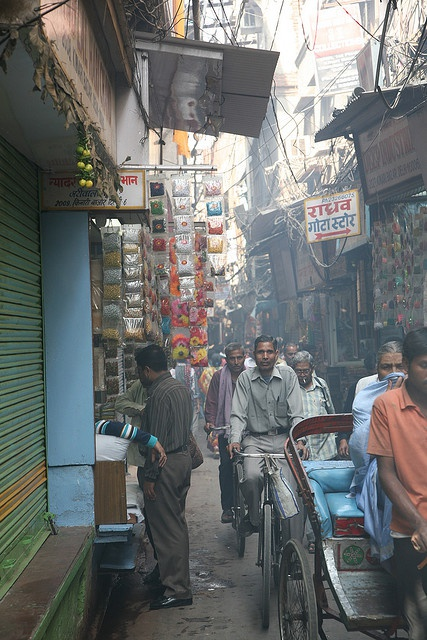Describe the objects in this image and their specific colors. I can see people in black, gray, and salmon tones, people in black, gray, darkgray, and purple tones, people in black, gray, and purple tones, people in black, gray, and blue tones, and bicycle in black, gray, purple, and darkgray tones in this image. 